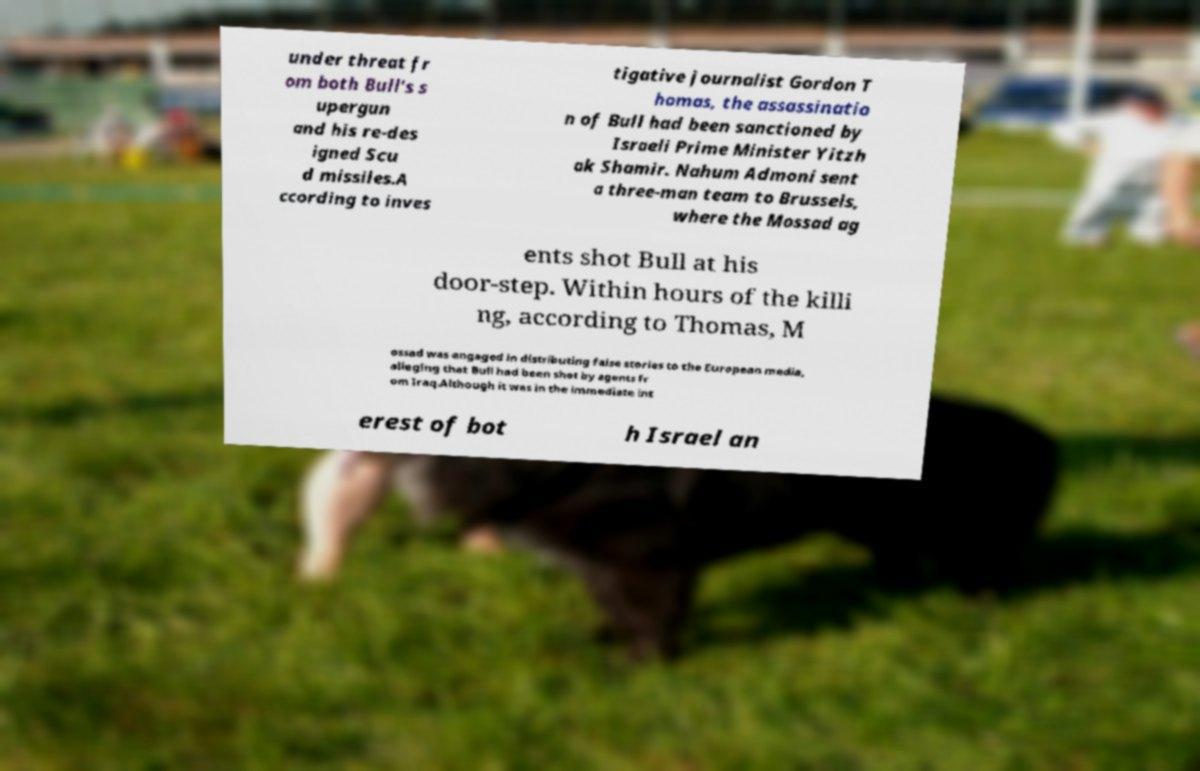Can you read and provide the text displayed in the image?This photo seems to have some interesting text. Can you extract and type it out for me? under threat fr om both Bull's s upergun and his re-des igned Scu d missiles.A ccording to inves tigative journalist Gordon T homas, the assassinatio n of Bull had been sanctioned by Israeli Prime Minister Yitzh ak Shamir. Nahum Admoni sent a three-man team to Brussels, where the Mossad ag ents shot Bull at his door-step. Within hours of the killi ng, according to Thomas, M ossad was engaged in distributing false stories to the European media, alleging that Bull had been shot by agents fr om Iraq.Although it was in the immediate int erest of bot h Israel an 